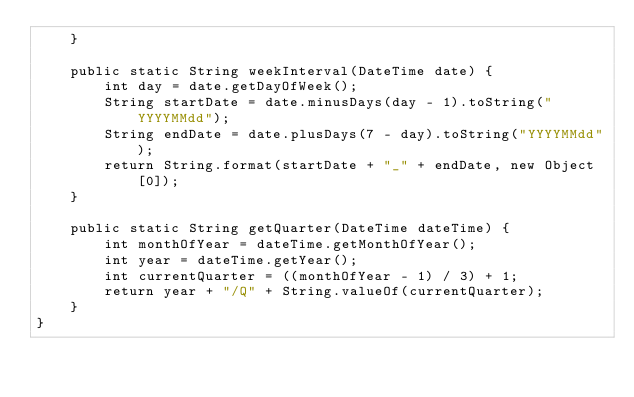Convert code to text. <code><loc_0><loc_0><loc_500><loc_500><_Java_>    }

    public static String weekInterval(DateTime date) {
        int day = date.getDayOfWeek();
        String startDate = date.minusDays(day - 1).toString("YYYYMMdd");
        String endDate = date.plusDays(7 - day).toString("YYYYMMdd");
        return String.format(startDate + "_" + endDate, new Object[0]);
    }

    public static String getQuarter(DateTime dateTime) {
        int monthOfYear = dateTime.getMonthOfYear();
        int year = dateTime.getYear();
        int currentQuarter = ((monthOfYear - 1) / 3) + 1;
        return year + "/Q" + String.valueOf(currentQuarter);
    }
}

</code> 